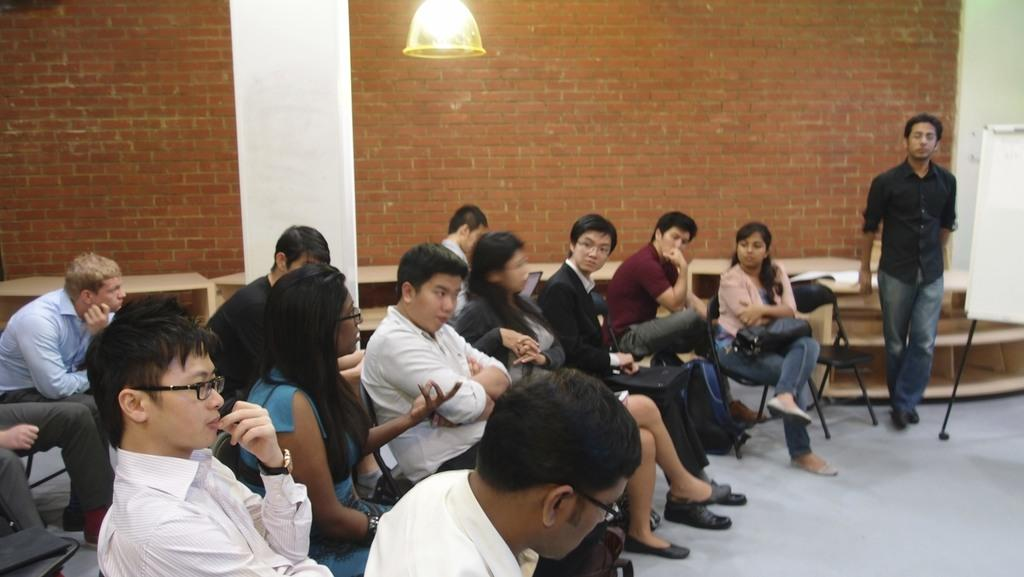What are most people in the image doing? Most people in the image are sitting on chairs. Can you describe the position of one man in the image? One man is standing in the image. What can be seen in the background of the image? There is a board, a wall, and a light in the background of the image. What type of ear is visible on the board in the image? There is no ear present on the board in the image. Can you describe the basin used for washing hands in the image? There is no basin for washing hands visible in the image. 